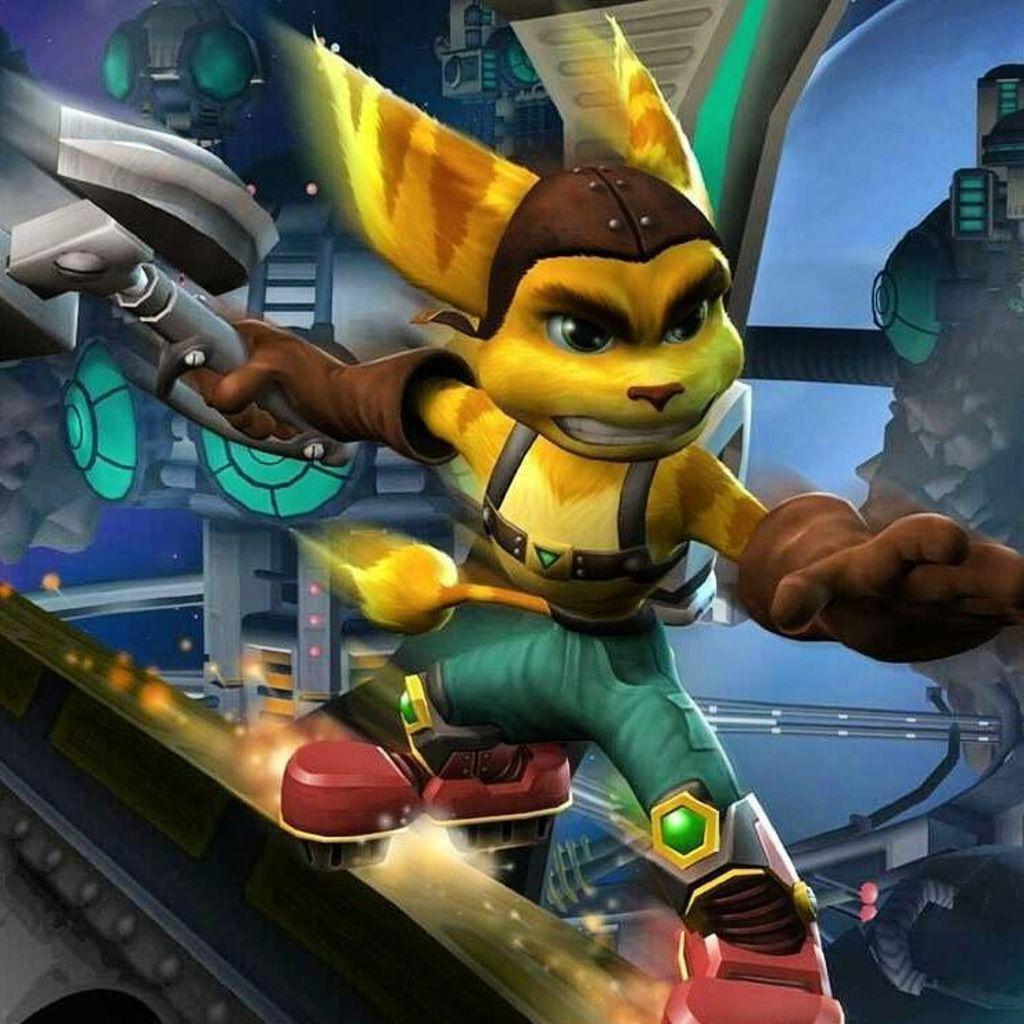Could you give a brief overview of what you see in this image? In this picture I can see animated image holding a weapon. 